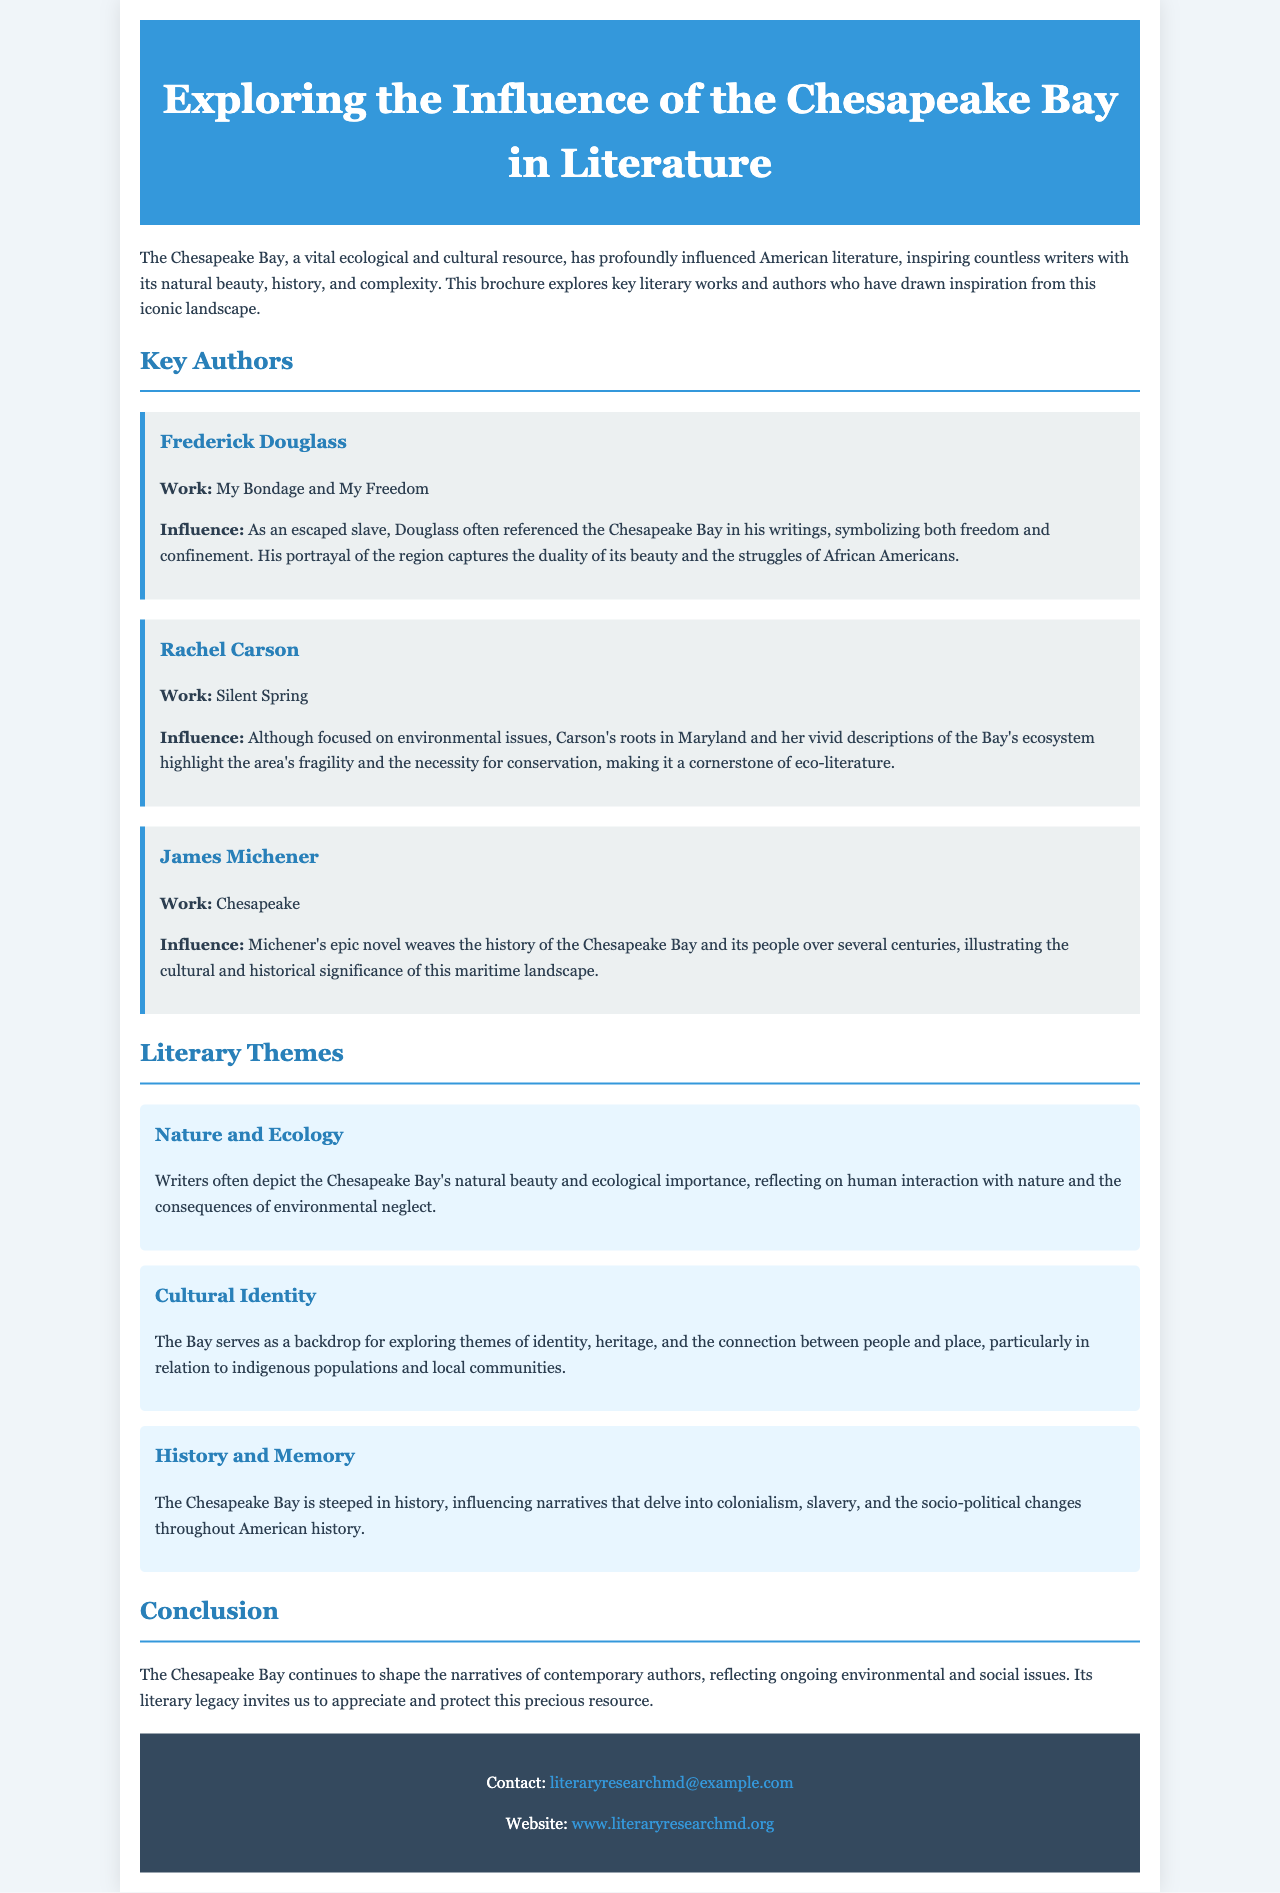What is the title of the brochure? The title is found at the top of the document in the header section.
Answer: Exploring the Influence of the Chesapeake Bay in Literature Who is the author of "My Bondage and My Freedom"? This information is available under the Key Authors section.
Answer: Frederick Douglass What major theme is highlighted in the literary works about the Chesapeake Bay? The themes are mentioned in the Literary Themes section of the brochure.
Answer: Nature and Ecology Which author wrote "Silent Spring"? This work is listed alongside the author's name in the Key Authors section.
Answer: Rachel Carson What does the Chesapeake Bay symbolize in Frederick Douglass's writings? The influence and symbolism are discussed under Douglass's entry in the brochure.
Answer: Freedom and confinement What type of resource is the Chesapeake Bay described as in the brochure? This is found in the opening paragraph describing its importance.
Answer: Vital ecological and cultural resource How many key authors are mentioned in the brochure? This requires counting the distinct author entries listed in the Key Authors section.
Answer: Three Which literary theme involves exploring identity and heritage? This theme is specified in the Literary Themes section of the brochure.
Answer: Cultural Identity What is the email address provided for contact? This information is found in the footer section of the document.
Answer: literaryresearchmd@example.com 